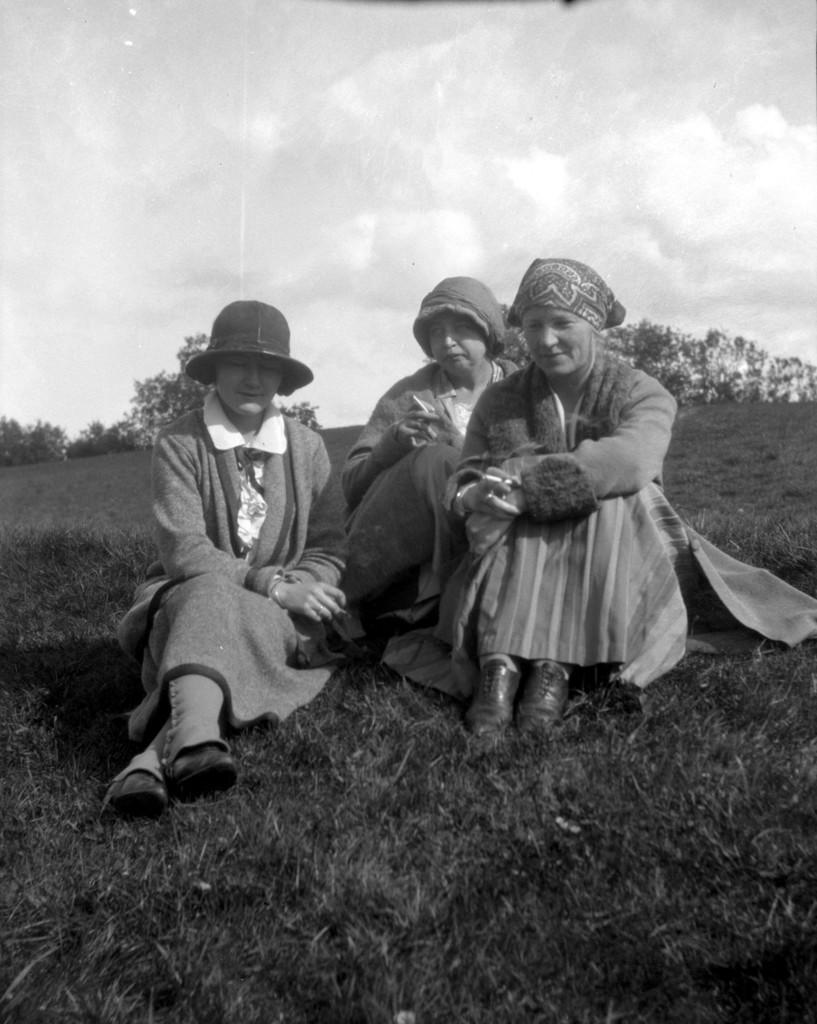How would you summarize this image in a sentence or two? In this picture we see 3 women wearing hats & sitting on the grass. The place is surrounded by trees. 